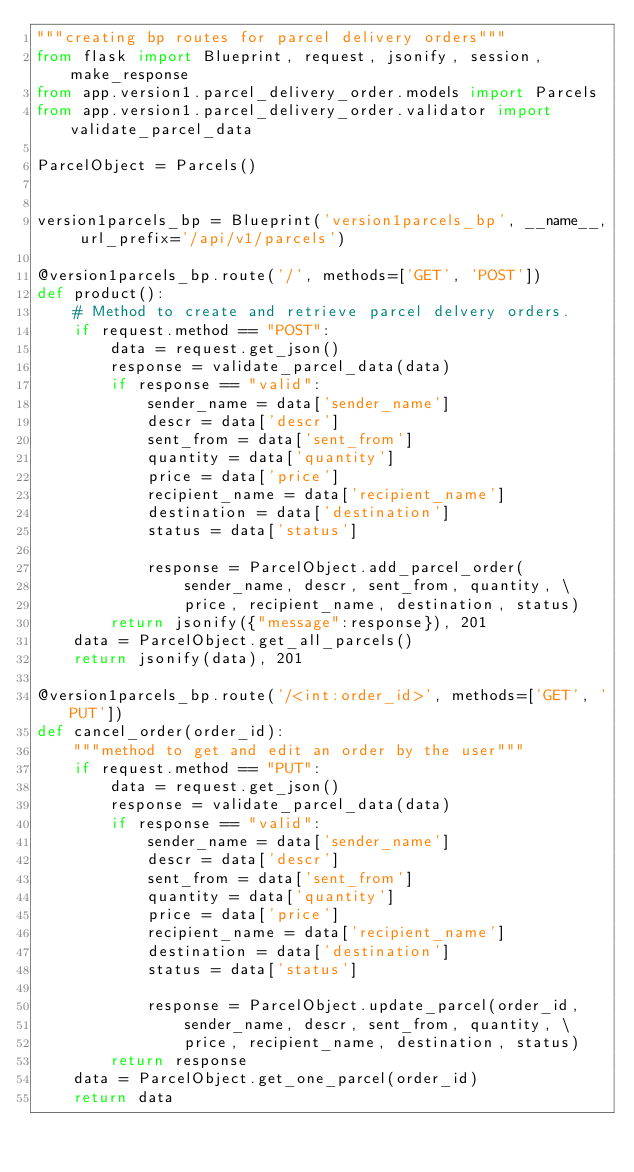<code> <loc_0><loc_0><loc_500><loc_500><_Python_>"""creating bp routes for parcel delivery orders"""
from flask import Blueprint, request, jsonify, session, make_response
from app.version1.parcel_delivery_order.models import Parcels
from app.version1.parcel_delivery_order.validator import validate_parcel_data

ParcelObject = Parcels()


version1parcels_bp = Blueprint('version1parcels_bp', __name__, url_prefix='/api/v1/parcels')

@version1parcels_bp.route('/', methods=['GET', 'POST'])
def product():
    # Method to create and retrieve parcel delvery orders.
    if request.method == "POST":
        data = request.get_json()
        response = validate_parcel_data(data)
        if response == "valid":
            sender_name = data['sender_name']
            descr = data['descr']
            sent_from = data['sent_from']
            quantity = data['quantity']
            price = data['price']
            recipient_name = data['recipient_name']
            destination = data['destination']
            status = data['status']

            response = ParcelObject.add_parcel_order(
                sender_name, descr, sent_from, quantity, \
                price, recipient_name, destination, status)
        return jsonify({"message":response}), 201
    data = ParcelObject.get_all_parcels()
    return jsonify(data), 201

@version1parcels_bp.route('/<int:order_id>', methods=['GET', 'PUT'])
def cancel_order(order_id):
    """method to get and edit an order by the user"""
    if request.method == "PUT":
        data = request.get_json()
        response = validate_parcel_data(data)
        if response == "valid":
            sender_name = data['sender_name']
            descr = data['descr']
            sent_from = data['sent_from']
            quantity = data['quantity']
            price = data['price']
            recipient_name = data['recipient_name']
            destination = data['destination']
            status = data['status']

            response = ParcelObject.update_parcel(order_id,
                sender_name, descr, sent_from, quantity, \
                price, recipient_name, destination, status)
        return response
    data = ParcelObject.get_one_parcel(order_id)
    return data

</code> 